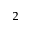Convert formula to latex. <formula><loc_0><loc_0><loc_500><loc_500>^ { 2 }</formula> 